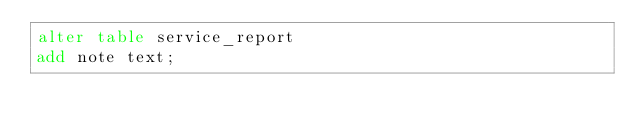Convert code to text. <code><loc_0><loc_0><loc_500><loc_500><_SQL_>alter table service_report
add note text;</code> 